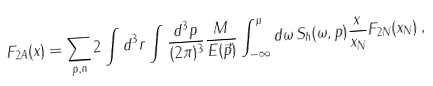<formula> <loc_0><loc_0><loc_500><loc_500>F _ { 2 A } ( x ) = \sum _ { p , n } 2 \int d ^ { 3 } r \int \frac { d ^ { 3 } p } { ( 2 \pi ) ^ { 3 } } \frac { M } { E ( \vec { p } ) } \int _ { - \infty } ^ { \mu } d \omega \, S _ { h } ( \omega , p ) \frac { x } { x _ { N } } F _ { 2 N } ( x _ { N } ) \, ,</formula> 